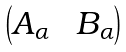Convert formula to latex. <formula><loc_0><loc_0><loc_500><loc_500>\begin{pmatrix} A _ { \alpha } \ & B _ { \alpha } \end{pmatrix}</formula> 